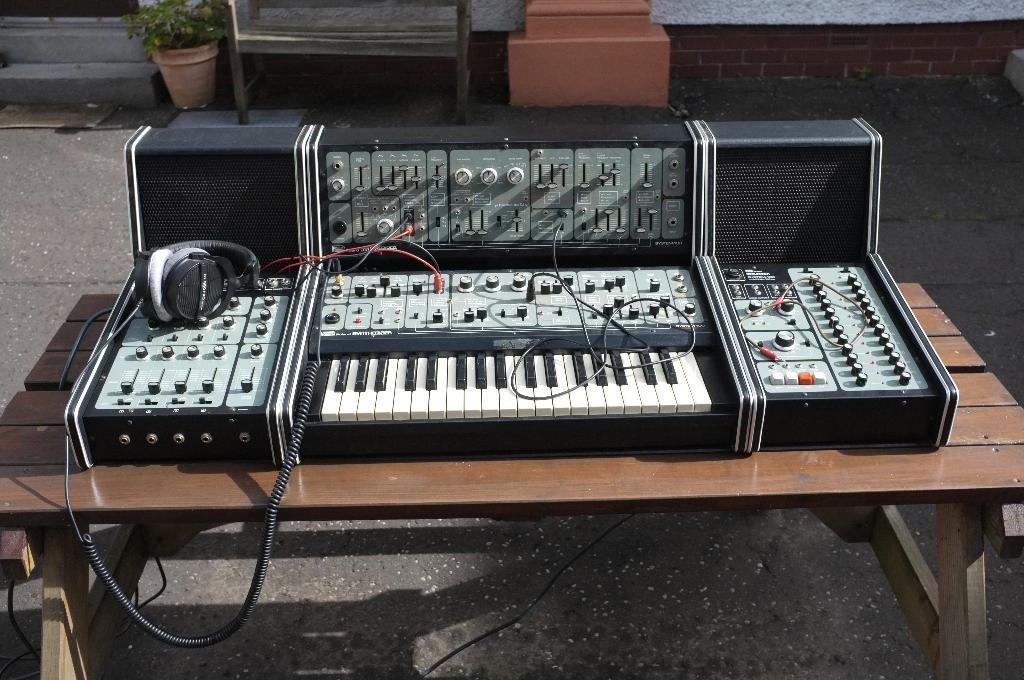How would you summarize this image in a sentence or two? In this image I can see a musical instrument and a headphone on this table. In the background I can see a plant. 